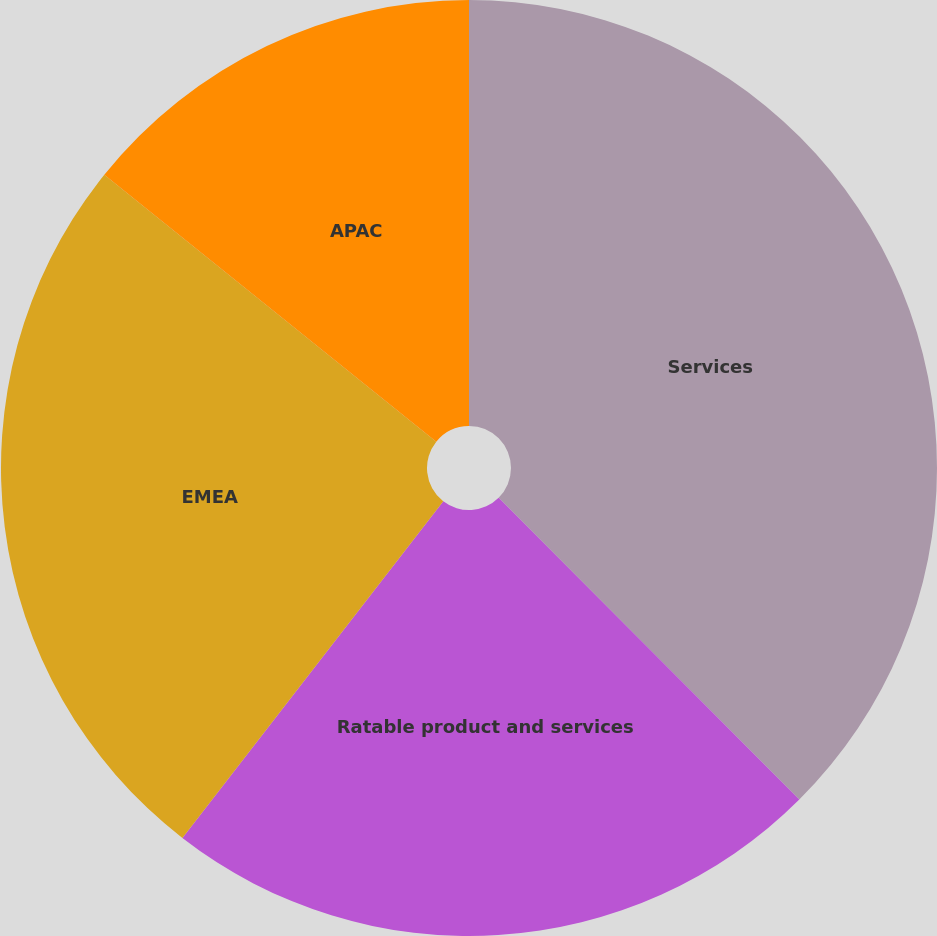Convert chart. <chart><loc_0><loc_0><loc_500><loc_500><pie_chart><fcel>Services<fcel>Ratable product and services<fcel>EMEA<fcel>APAC<nl><fcel>37.53%<fcel>22.96%<fcel>25.29%<fcel>14.22%<nl></chart> 